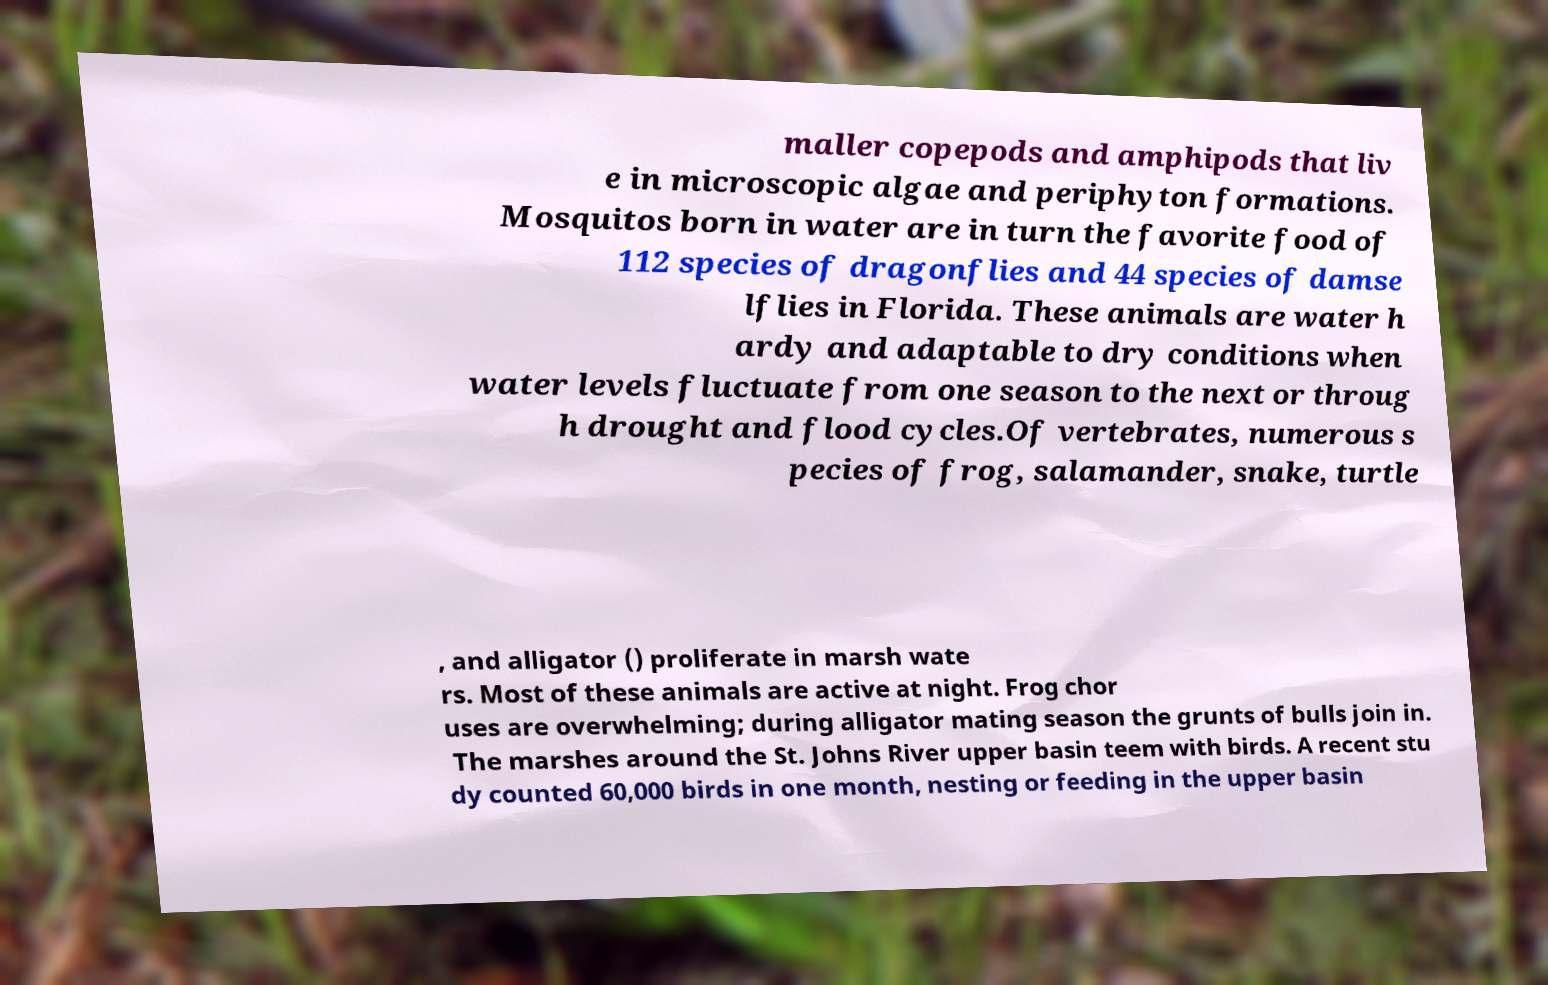Could you assist in decoding the text presented in this image and type it out clearly? maller copepods and amphipods that liv e in microscopic algae and periphyton formations. Mosquitos born in water are in turn the favorite food of 112 species of dragonflies and 44 species of damse lflies in Florida. These animals are water h ardy and adaptable to dry conditions when water levels fluctuate from one season to the next or throug h drought and flood cycles.Of vertebrates, numerous s pecies of frog, salamander, snake, turtle , and alligator () proliferate in marsh wate rs. Most of these animals are active at night. Frog chor uses are overwhelming; during alligator mating season the grunts of bulls join in. The marshes around the St. Johns River upper basin teem with birds. A recent stu dy counted 60,000 birds in one month, nesting or feeding in the upper basin 